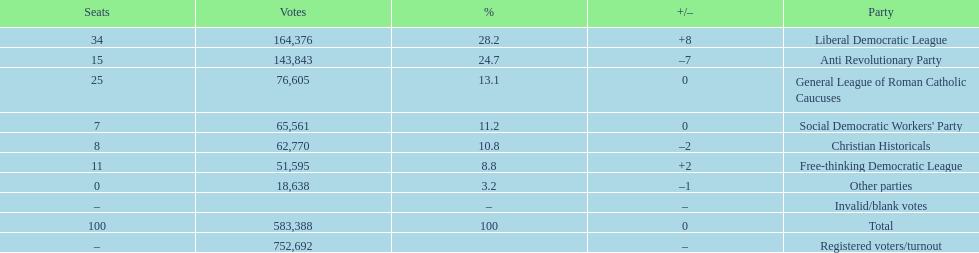Name the top three parties? Liberal Democratic League, Anti Revolutionary Party, General League of Roman Catholic Caucuses. 